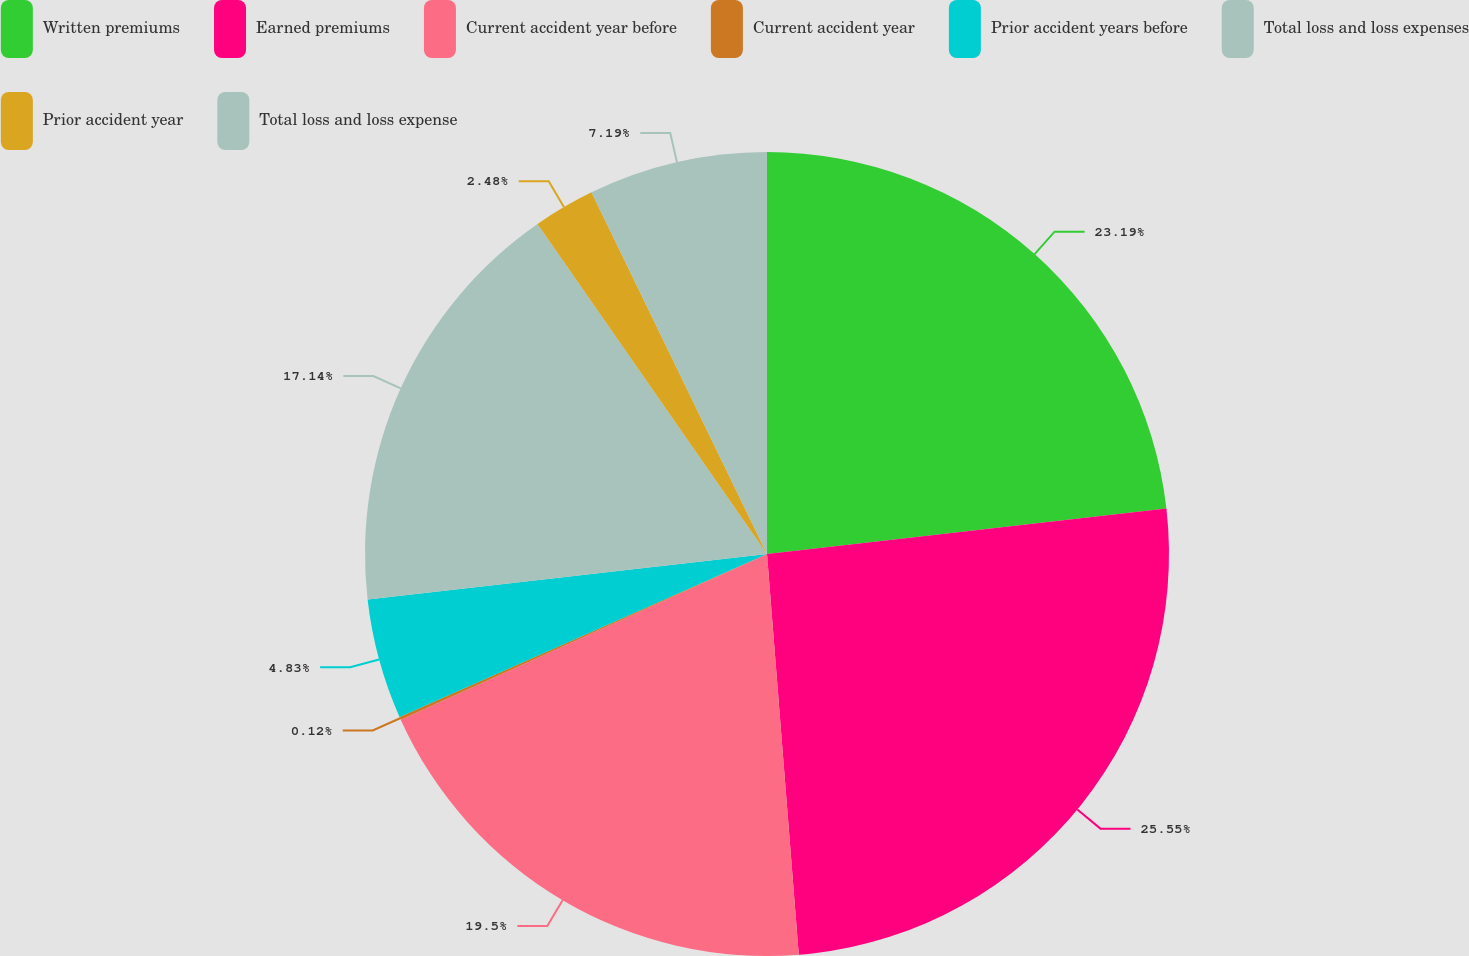Convert chart. <chart><loc_0><loc_0><loc_500><loc_500><pie_chart><fcel>Written premiums<fcel>Earned premiums<fcel>Current accident year before<fcel>Current accident year<fcel>Prior accident years before<fcel>Total loss and loss expenses<fcel>Prior accident year<fcel>Total loss and loss expense<nl><fcel>23.19%<fcel>25.55%<fcel>19.5%<fcel>0.12%<fcel>4.83%<fcel>17.14%<fcel>2.48%<fcel>7.19%<nl></chart> 